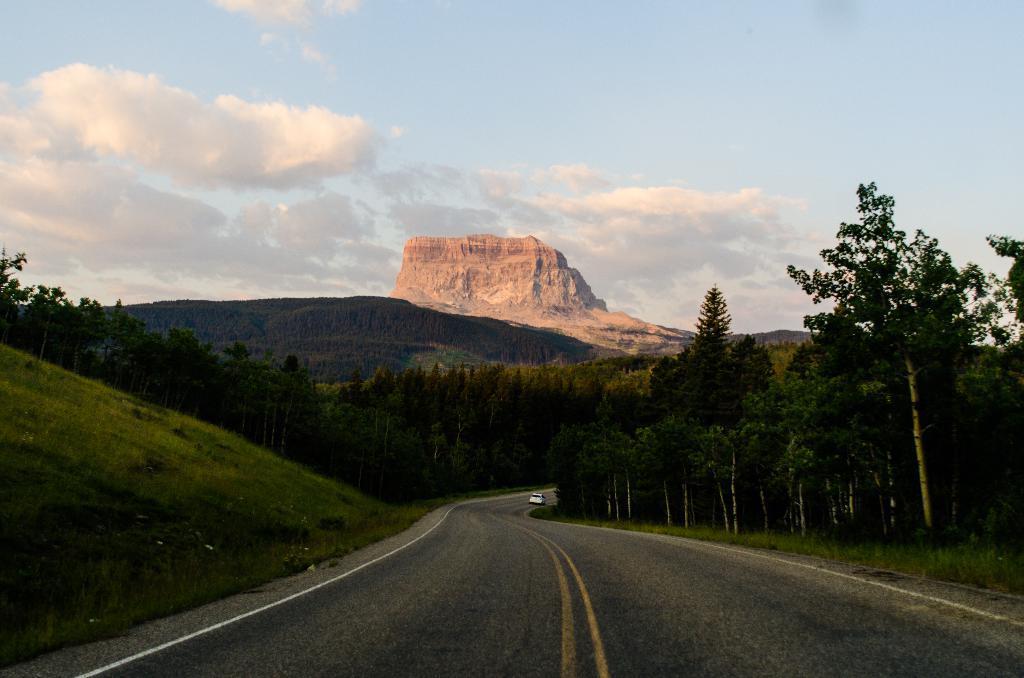Describe this image in one or two sentences. In the center of the image we can see a car on the road. In the background, we can see the sky, clouds, hills, trees and grass. 